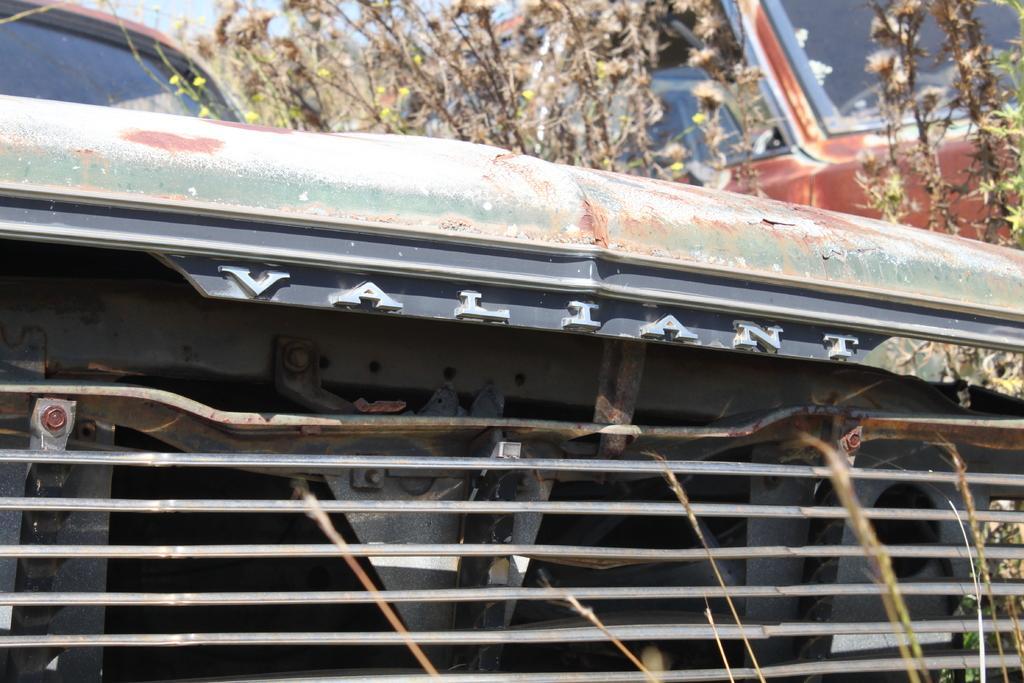Can you describe this image briefly? This is a zoomed in picture of a car. There are plants. 